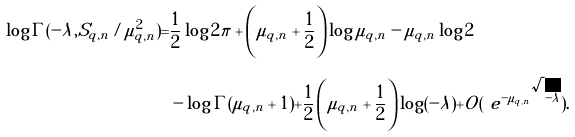Convert formula to latex. <formula><loc_0><loc_0><loc_500><loc_500>\log \Gamma ( - \lambda , S _ { q , n } / \mu _ { q , n } ^ { 2 } ) = & \frac { 1 } { 2 } \log 2 \pi + \left ( \mu _ { q , n } + \frac { 1 } { 2 } \right ) \log \mu _ { q , n } - \mu _ { q , n } \log 2 \\ & - \log \Gamma ( \mu _ { q , n } + 1 ) + \frac { 1 } { 2 } \left ( \mu _ { q , n } + \frac { 1 } { 2 } \right ) \log ( - \lambda ) + O ( \ e ^ { - \mu _ { q , n } \sqrt { - \lambda } } ) .</formula> 